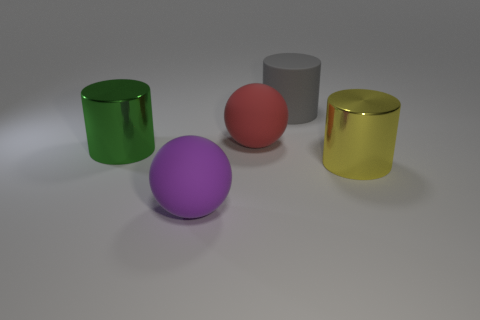Do the green object and the large purple object have the same shape?
Provide a succinct answer. No. There is a metallic thing in front of the object to the left of the large rubber object in front of the large yellow object; how big is it?
Make the answer very short. Large. What is the material of the big red thing?
Provide a short and direct response. Rubber. There is a green shiny object; does it have the same shape as the large metal thing on the right side of the purple thing?
Make the answer very short. Yes. There is a ball that is in front of the metal cylinder to the left of the thing behind the red thing; what is its material?
Give a very brief answer. Rubber. How many purple matte spheres are there?
Ensure brevity in your answer.  1. How many green things are big cylinders or objects?
Keep it short and to the point. 1. What number of other objects are there of the same shape as the big green shiny thing?
Offer a very short reply. 2. There is a matte sphere in front of the green shiny cylinder; is its color the same as the large cylinder that is to the right of the gray cylinder?
Offer a very short reply. No. How many tiny things are either rubber objects or blue matte cubes?
Provide a short and direct response. 0. 